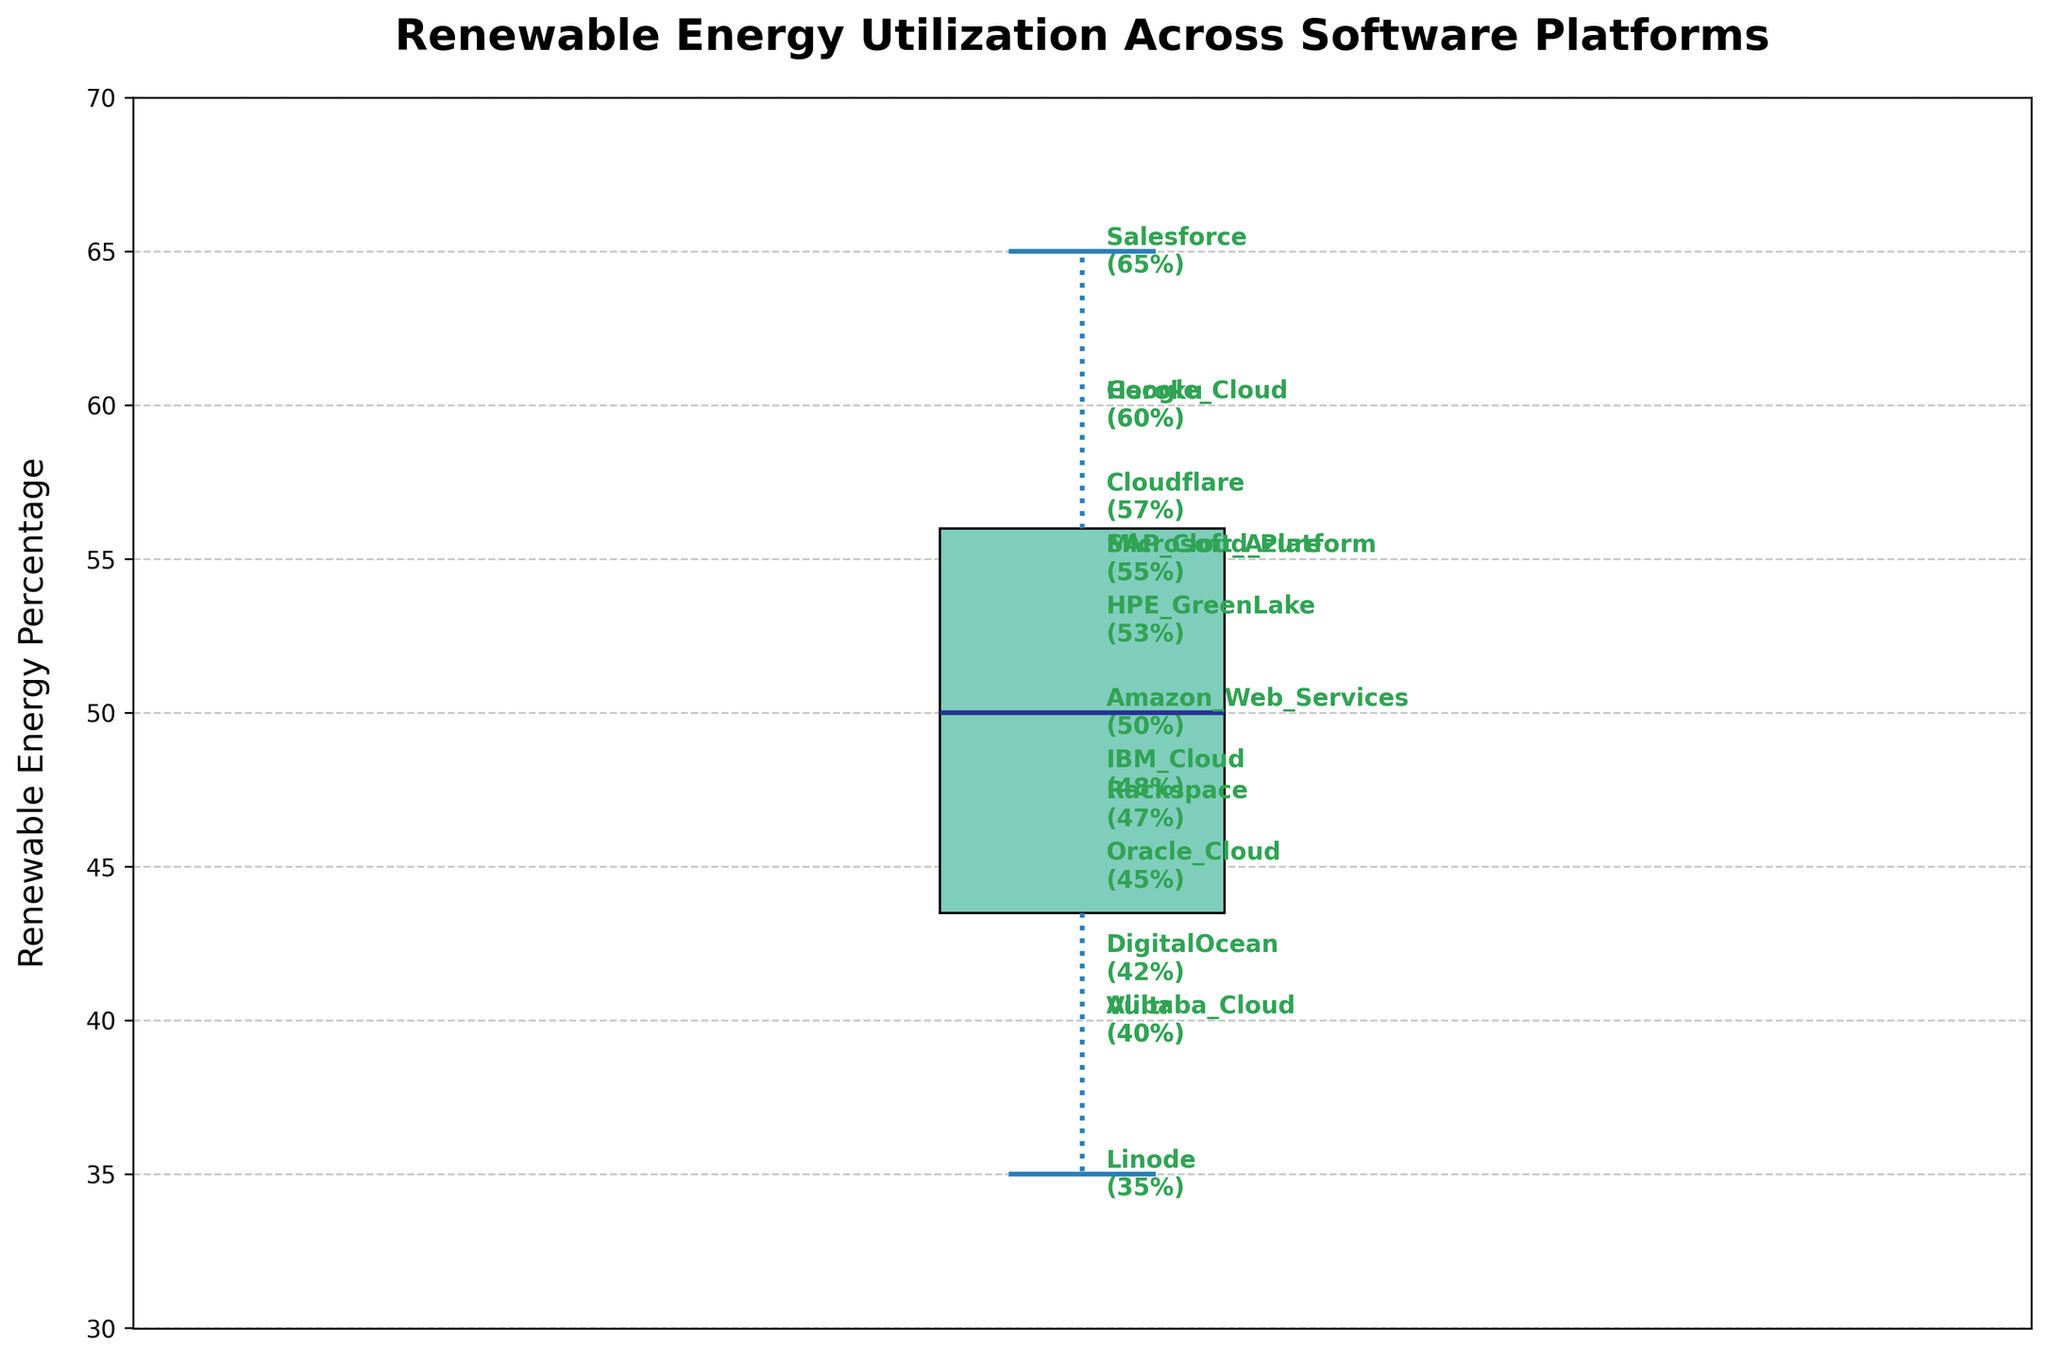What is the title of the box plot? The title of a figure is usually located at the top center of the plot and provides a brief description of what the figure represents. In this case, the title is clearly shown as 'Renewable Energy Utilization Across Software Platforms'.
Answer: Renewable Energy Utilization Across Software Platforms What is the median Renewable Energy Percentage? The median is indicated by the line in the middle of the box in a box plot. In this case, the median line is around 50%.
Answer: 50% Which platform has the highest Renewable Energy Percentage annotated in the plot? The annotated labels show each platform and their respective Renewable Energy Percentage. The highest percentage is displayed next to Salesforce, which has a value of 65%.
Answer: Salesforce What is the range of Renewable Energy Percentages in the data? The range is the difference between the maximum and minimum values. The highest percentage is 65% (Salesforce), and the lowest is 35% (Linode). Thus, the range is 65% - 35% = 30%.
Answer: 30% How many platforms have a Renewable Energy Percentage greater than 55%? By examining the annotated percentages, we can identify the platforms above 55%. They are Google Cloud (60%), Salesforce (65%), Heroku (60%), and Cloudflare (57%). Therefore, there are 4 platforms.
Answer: 4 What is the interquartile range (IQR) of the Renewable Energy Percentage? The IQR is the range between the first quartile (25th percentile) and the third quartile (75th percentile) in a box plot. The lower whisker represents the 25th percentile (~45%), and the upper whisker represents the 75th percentile (~57%). Hence, IQR = 57% - 45% = 12%.
Answer: 12% Which platforms fall outside the inner fences (potential outliers)? Potential outliers in a box plot are represented by points outside the whiskers. There are no external points or markers outside the whiskers in this box plot, indicating no platforms fall outside the inner fences.
Answer: None Which platform has a similar Renewable Energy Percentage to Microsoft Azure? Microsoft Azure has a Renewable Energy Percentage of 55%. SAP Cloud Platform also has the same percentage of 55%, making it similar in this respect.
Answer: SAP Cloud Platform 